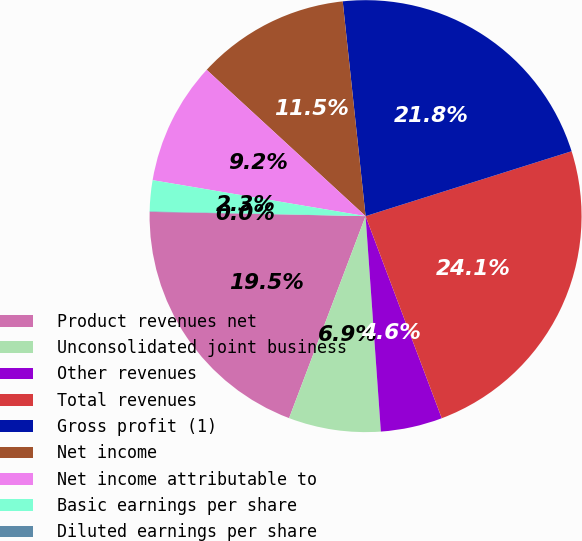Convert chart. <chart><loc_0><loc_0><loc_500><loc_500><pie_chart><fcel>Product revenues net<fcel>Unconsolidated joint business<fcel>Other revenues<fcel>Total revenues<fcel>Gross profit (1)<fcel>Net income<fcel>Net income attributable to<fcel>Basic earnings per share<fcel>Diluted earnings per share<nl><fcel>19.55%<fcel>6.89%<fcel>4.61%<fcel>24.12%<fcel>21.83%<fcel>11.47%<fcel>9.18%<fcel>2.32%<fcel>0.03%<nl></chart> 